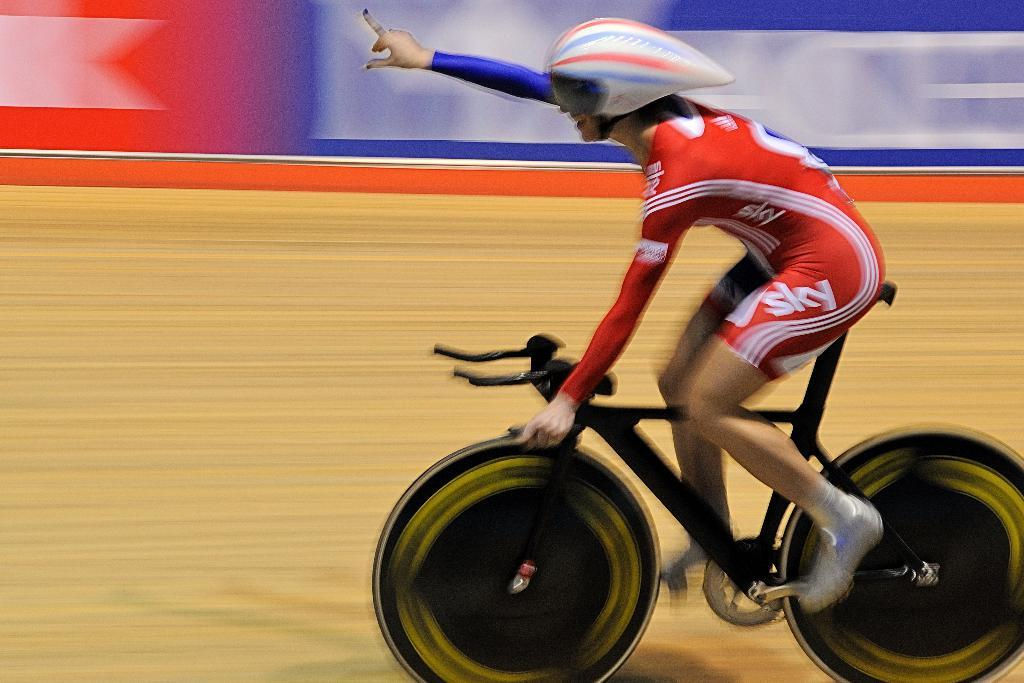<image>
Share a concise interpretation of the image provided. An indoor cyclist is wearing a uniform with the word sky on it. 